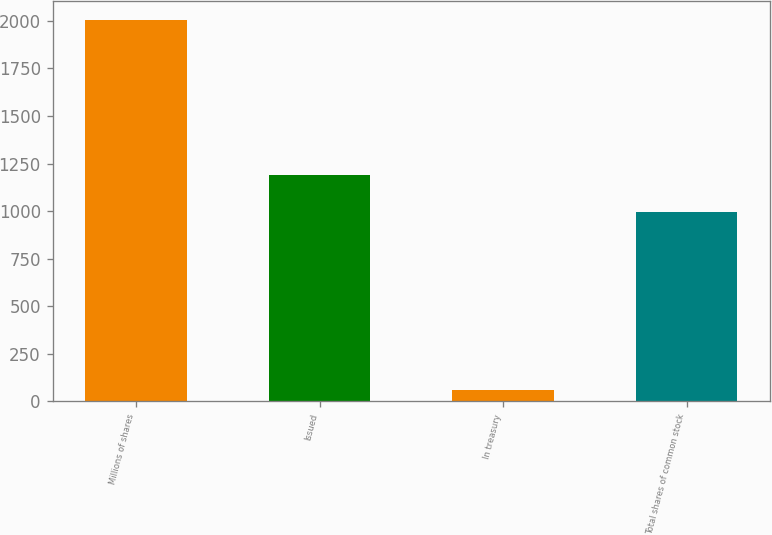Convert chart. <chart><loc_0><loc_0><loc_500><loc_500><bar_chart><fcel>Millions of shares<fcel>Issued<fcel>In treasury<fcel>Total shares of common stock<nl><fcel>2006<fcel>1192.4<fcel>62<fcel>998<nl></chart> 